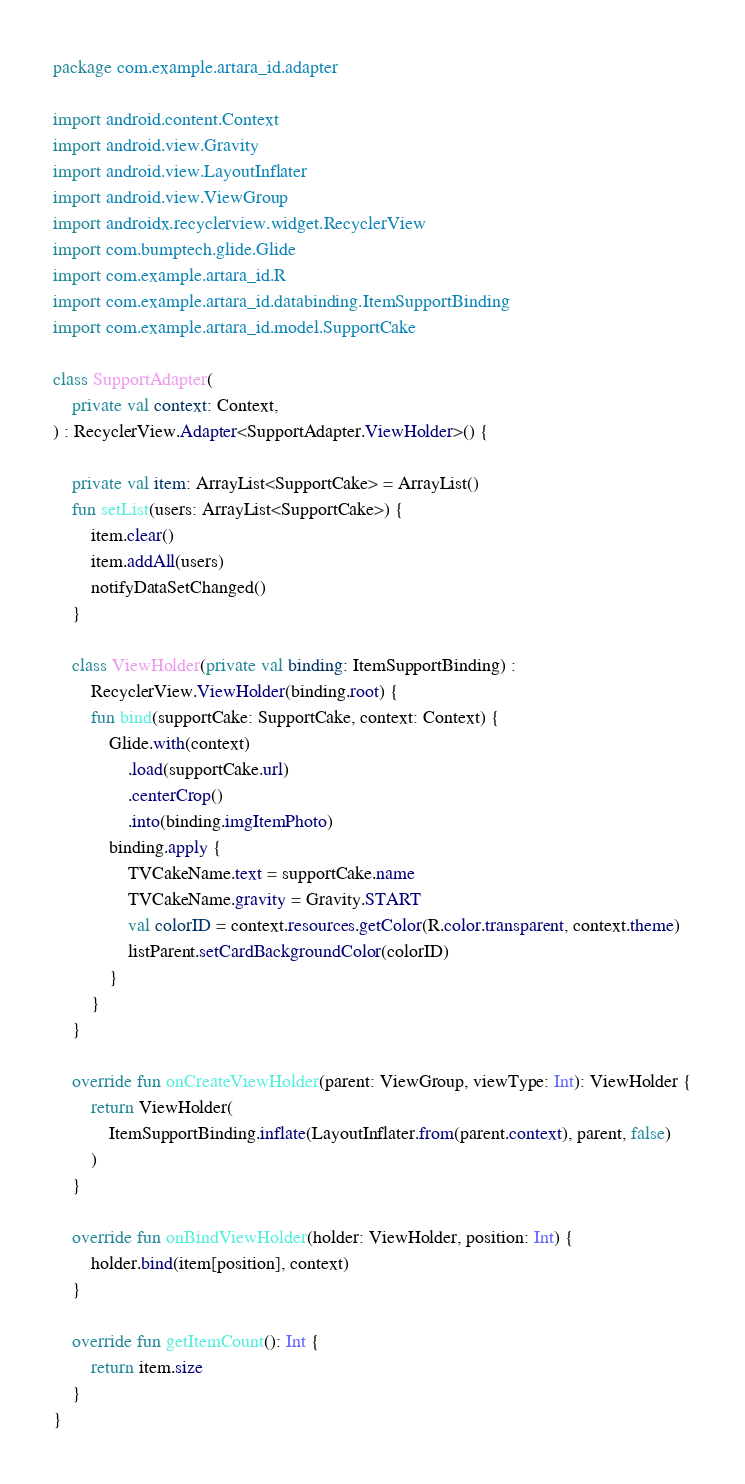Convert code to text. <code><loc_0><loc_0><loc_500><loc_500><_Kotlin_>package com.example.artara_id.adapter

import android.content.Context
import android.view.Gravity
import android.view.LayoutInflater
import android.view.ViewGroup
import androidx.recyclerview.widget.RecyclerView
import com.bumptech.glide.Glide
import com.example.artara_id.R
import com.example.artara_id.databinding.ItemSupportBinding
import com.example.artara_id.model.SupportCake

class SupportAdapter(
    private val context: Context,
) : RecyclerView.Adapter<SupportAdapter.ViewHolder>() {

    private val item: ArrayList<SupportCake> = ArrayList()
    fun setList(users: ArrayList<SupportCake>) {
        item.clear()
        item.addAll(users)
        notifyDataSetChanged()
    }

    class ViewHolder(private val binding: ItemSupportBinding) :
        RecyclerView.ViewHolder(binding.root) {
        fun bind(supportCake: SupportCake, context: Context) {
            Glide.with(context)
                .load(supportCake.url)
                .centerCrop()
                .into(binding.imgItemPhoto)
            binding.apply {
                TVCakeName.text = supportCake.name
                TVCakeName.gravity = Gravity.START
                val colorID = context.resources.getColor(R.color.transparent, context.theme)
                listParent.setCardBackgroundColor(colorID)
            }
        }
    }

    override fun onCreateViewHolder(parent: ViewGroup, viewType: Int): ViewHolder {
        return ViewHolder(
            ItemSupportBinding.inflate(LayoutInflater.from(parent.context), parent, false)
        )
    }

    override fun onBindViewHolder(holder: ViewHolder, position: Int) {
        holder.bind(item[position], context)
    }

    override fun getItemCount(): Int {
        return item.size
    }
}</code> 